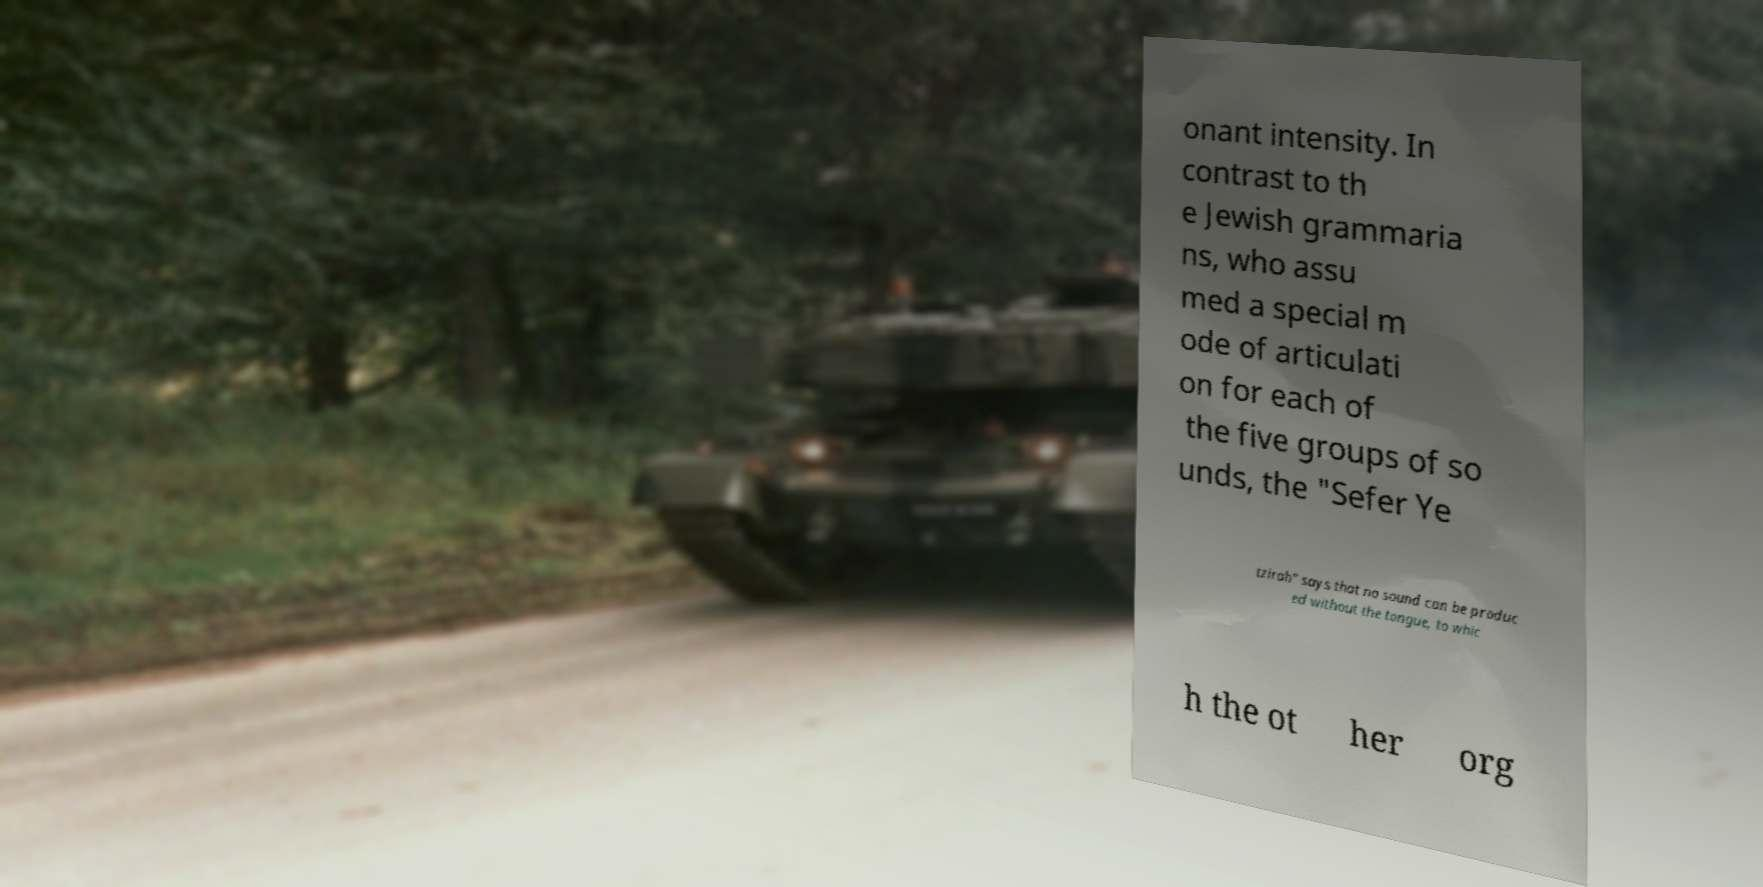Please read and relay the text visible in this image. What does it say? onant intensity. In contrast to th e Jewish grammaria ns, who assu med a special m ode of articulati on for each of the five groups of so unds, the "Sefer Ye tzirah" says that no sound can be produc ed without the tongue, to whic h the ot her org 